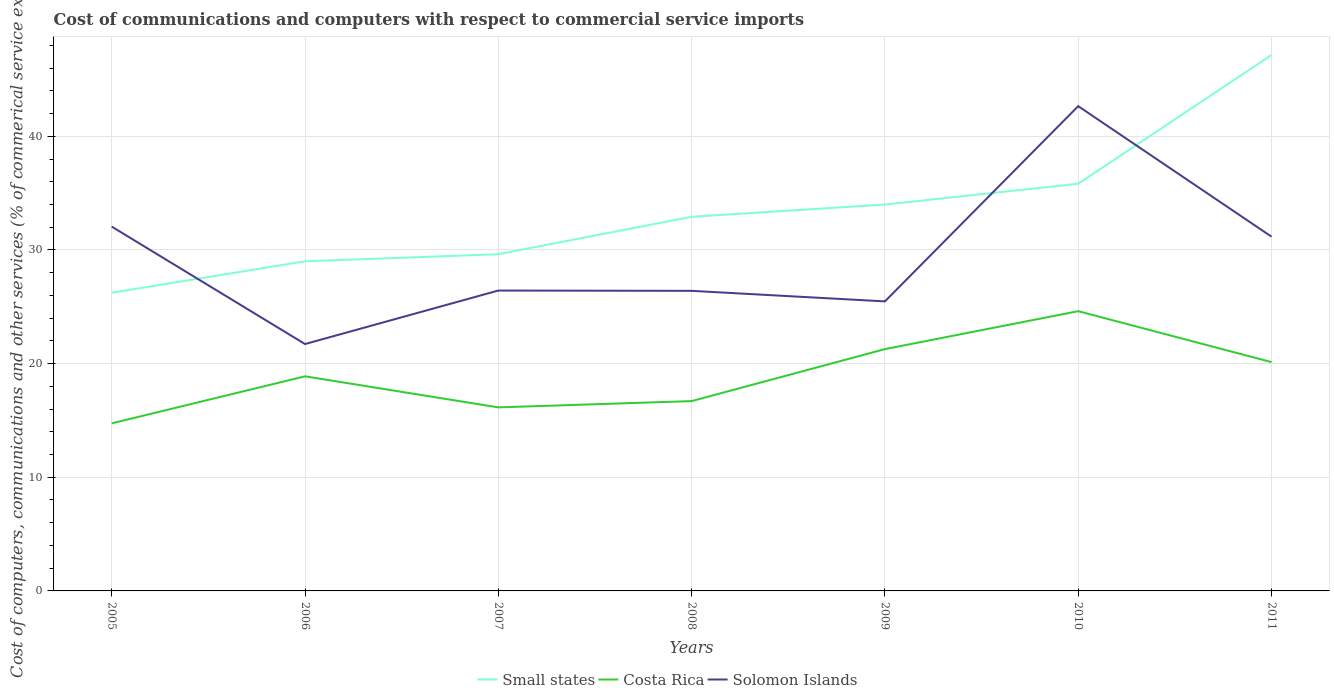How many different coloured lines are there?
Your answer should be very brief. 3. Does the line corresponding to Solomon Islands intersect with the line corresponding to Small states?
Provide a succinct answer. Yes. Across all years, what is the maximum cost of communications and computers in Small states?
Ensure brevity in your answer.  26.24. In which year was the cost of communications and computers in Costa Rica maximum?
Your answer should be very brief. 2005. What is the total cost of communications and computers in Solomon Islands in the graph?
Offer a terse response. 0.95. What is the difference between the highest and the second highest cost of communications and computers in Costa Rica?
Your response must be concise. 9.87. What is the difference between the highest and the lowest cost of communications and computers in Small states?
Make the answer very short. 3. Is the cost of communications and computers in Solomon Islands strictly greater than the cost of communications and computers in Small states over the years?
Offer a terse response. No. Does the graph contain any zero values?
Your response must be concise. No. Does the graph contain grids?
Provide a succinct answer. Yes. Where does the legend appear in the graph?
Your answer should be very brief. Bottom center. How many legend labels are there?
Your response must be concise. 3. How are the legend labels stacked?
Ensure brevity in your answer.  Horizontal. What is the title of the graph?
Offer a very short reply. Cost of communications and computers with respect to commercial service imports. What is the label or title of the X-axis?
Ensure brevity in your answer.  Years. What is the label or title of the Y-axis?
Keep it short and to the point. Cost of computers, communications and other services (% of commerical service exports). What is the Cost of computers, communications and other services (% of commerical service exports) in Small states in 2005?
Give a very brief answer. 26.24. What is the Cost of computers, communications and other services (% of commerical service exports) of Costa Rica in 2005?
Give a very brief answer. 14.74. What is the Cost of computers, communications and other services (% of commerical service exports) in Solomon Islands in 2005?
Give a very brief answer. 32.05. What is the Cost of computers, communications and other services (% of commerical service exports) in Small states in 2006?
Provide a short and direct response. 29. What is the Cost of computers, communications and other services (% of commerical service exports) of Costa Rica in 2006?
Provide a succinct answer. 18.88. What is the Cost of computers, communications and other services (% of commerical service exports) of Solomon Islands in 2006?
Provide a short and direct response. 21.72. What is the Cost of computers, communications and other services (% of commerical service exports) of Small states in 2007?
Keep it short and to the point. 29.62. What is the Cost of computers, communications and other services (% of commerical service exports) in Costa Rica in 2007?
Provide a short and direct response. 16.15. What is the Cost of computers, communications and other services (% of commerical service exports) of Solomon Islands in 2007?
Your answer should be very brief. 26.43. What is the Cost of computers, communications and other services (% of commerical service exports) in Small states in 2008?
Ensure brevity in your answer.  32.92. What is the Cost of computers, communications and other services (% of commerical service exports) of Costa Rica in 2008?
Your answer should be compact. 16.7. What is the Cost of computers, communications and other services (% of commerical service exports) in Solomon Islands in 2008?
Provide a short and direct response. 26.4. What is the Cost of computers, communications and other services (% of commerical service exports) of Small states in 2009?
Provide a short and direct response. 33.99. What is the Cost of computers, communications and other services (% of commerical service exports) in Costa Rica in 2009?
Offer a terse response. 21.27. What is the Cost of computers, communications and other services (% of commerical service exports) in Solomon Islands in 2009?
Offer a very short reply. 25.47. What is the Cost of computers, communications and other services (% of commerical service exports) in Small states in 2010?
Keep it short and to the point. 35.83. What is the Cost of computers, communications and other services (% of commerical service exports) in Costa Rica in 2010?
Provide a succinct answer. 24.61. What is the Cost of computers, communications and other services (% of commerical service exports) in Solomon Islands in 2010?
Provide a short and direct response. 42.65. What is the Cost of computers, communications and other services (% of commerical service exports) of Small states in 2011?
Give a very brief answer. 47.15. What is the Cost of computers, communications and other services (% of commerical service exports) in Costa Rica in 2011?
Offer a very short reply. 20.13. What is the Cost of computers, communications and other services (% of commerical service exports) of Solomon Islands in 2011?
Offer a terse response. 31.17. Across all years, what is the maximum Cost of computers, communications and other services (% of commerical service exports) of Small states?
Keep it short and to the point. 47.15. Across all years, what is the maximum Cost of computers, communications and other services (% of commerical service exports) in Costa Rica?
Provide a succinct answer. 24.61. Across all years, what is the maximum Cost of computers, communications and other services (% of commerical service exports) of Solomon Islands?
Provide a short and direct response. 42.65. Across all years, what is the minimum Cost of computers, communications and other services (% of commerical service exports) of Small states?
Your response must be concise. 26.24. Across all years, what is the minimum Cost of computers, communications and other services (% of commerical service exports) of Costa Rica?
Your answer should be compact. 14.74. Across all years, what is the minimum Cost of computers, communications and other services (% of commerical service exports) of Solomon Islands?
Offer a very short reply. 21.72. What is the total Cost of computers, communications and other services (% of commerical service exports) of Small states in the graph?
Your response must be concise. 234.75. What is the total Cost of computers, communications and other services (% of commerical service exports) in Costa Rica in the graph?
Offer a terse response. 132.49. What is the total Cost of computers, communications and other services (% of commerical service exports) in Solomon Islands in the graph?
Provide a short and direct response. 205.9. What is the difference between the Cost of computers, communications and other services (% of commerical service exports) of Small states in 2005 and that in 2006?
Your answer should be compact. -2.77. What is the difference between the Cost of computers, communications and other services (% of commerical service exports) in Costa Rica in 2005 and that in 2006?
Your response must be concise. -4.14. What is the difference between the Cost of computers, communications and other services (% of commerical service exports) of Solomon Islands in 2005 and that in 2006?
Offer a terse response. 10.33. What is the difference between the Cost of computers, communications and other services (% of commerical service exports) in Small states in 2005 and that in 2007?
Make the answer very short. -3.39. What is the difference between the Cost of computers, communications and other services (% of commerical service exports) of Costa Rica in 2005 and that in 2007?
Give a very brief answer. -1.41. What is the difference between the Cost of computers, communications and other services (% of commerical service exports) of Solomon Islands in 2005 and that in 2007?
Keep it short and to the point. 5.63. What is the difference between the Cost of computers, communications and other services (% of commerical service exports) in Small states in 2005 and that in 2008?
Your response must be concise. -6.68. What is the difference between the Cost of computers, communications and other services (% of commerical service exports) of Costa Rica in 2005 and that in 2008?
Your answer should be compact. -1.96. What is the difference between the Cost of computers, communications and other services (% of commerical service exports) of Solomon Islands in 2005 and that in 2008?
Your answer should be very brief. 5.65. What is the difference between the Cost of computers, communications and other services (% of commerical service exports) in Small states in 2005 and that in 2009?
Provide a succinct answer. -7.76. What is the difference between the Cost of computers, communications and other services (% of commerical service exports) in Costa Rica in 2005 and that in 2009?
Your answer should be compact. -6.53. What is the difference between the Cost of computers, communications and other services (% of commerical service exports) in Solomon Islands in 2005 and that in 2009?
Keep it short and to the point. 6.58. What is the difference between the Cost of computers, communications and other services (% of commerical service exports) in Small states in 2005 and that in 2010?
Your answer should be compact. -9.59. What is the difference between the Cost of computers, communications and other services (% of commerical service exports) in Costa Rica in 2005 and that in 2010?
Your answer should be very brief. -9.87. What is the difference between the Cost of computers, communications and other services (% of commerical service exports) in Solomon Islands in 2005 and that in 2010?
Make the answer very short. -10.6. What is the difference between the Cost of computers, communications and other services (% of commerical service exports) of Small states in 2005 and that in 2011?
Your answer should be compact. -20.92. What is the difference between the Cost of computers, communications and other services (% of commerical service exports) of Costa Rica in 2005 and that in 2011?
Give a very brief answer. -5.39. What is the difference between the Cost of computers, communications and other services (% of commerical service exports) of Solomon Islands in 2005 and that in 2011?
Offer a very short reply. 0.88. What is the difference between the Cost of computers, communications and other services (% of commerical service exports) in Small states in 2006 and that in 2007?
Offer a terse response. -0.62. What is the difference between the Cost of computers, communications and other services (% of commerical service exports) of Costa Rica in 2006 and that in 2007?
Your answer should be compact. 2.73. What is the difference between the Cost of computers, communications and other services (% of commerical service exports) in Solomon Islands in 2006 and that in 2007?
Ensure brevity in your answer.  -4.71. What is the difference between the Cost of computers, communications and other services (% of commerical service exports) in Small states in 2006 and that in 2008?
Your answer should be compact. -3.92. What is the difference between the Cost of computers, communications and other services (% of commerical service exports) in Costa Rica in 2006 and that in 2008?
Offer a very short reply. 2.18. What is the difference between the Cost of computers, communications and other services (% of commerical service exports) in Solomon Islands in 2006 and that in 2008?
Provide a short and direct response. -4.68. What is the difference between the Cost of computers, communications and other services (% of commerical service exports) of Small states in 2006 and that in 2009?
Make the answer very short. -4.99. What is the difference between the Cost of computers, communications and other services (% of commerical service exports) in Costa Rica in 2006 and that in 2009?
Your answer should be compact. -2.39. What is the difference between the Cost of computers, communications and other services (% of commerical service exports) in Solomon Islands in 2006 and that in 2009?
Your answer should be compact. -3.75. What is the difference between the Cost of computers, communications and other services (% of commerical service exports) of Small states in 2006 and that in 2010?
Give a very brief answer. -6.83. What is the difference between the Cost of computers, communications and other services (% of commerical service exports) of Costa Rica in 2006 and that in 2010?
Your answer should be compact. -5.73. What is the difference between the Cost of computers, communications and other services (% of commerical service exports) of Solomon Islands in 2006 and that in 2010?
Your answer should be compact. -20.93. What is the difference between the Cost of computers, communications and other services (% of commerical service exports) in Small states in 2006 and that in 2011?
Make the answer very short. -18.15. What is the difference between the Cost of computers, communications and other services (% of commerical service exports) of Costa Rica in 2006 and that in 2011?
Your answer should be compact. -1.25. What is the difference between the Cost of computers, communications and other services (% of commerical service exports) in Solomon Islands in 2006 and that in 2011?
Provide a short and direct response. -9.45. What is the difference between the Cost of computers, communications and other services (% of commerical service exports) of Small states in 2007 and that in 2008?
Provide a short and direct response. -3.29. What is the difference between the Cost of computers, communications and other services (% of commerical service exports) in Costa Rica in 2007 and that in 2008?
Make the answer very short. -0.55. What is the difference between the Cost of computers, communications and other services (% of commerical service exports) in Solomon Islands in 2007 and that in 2008?
Your response must be concise. 0.03. What is the difference between the Cost of computers, communications and other services (% of commerical service exports) in Small states in 2007 and that in 2009?
Make the answer very short. -4.37. What is the difference between the Cost of computers, communications and other services (% of commerical service exports) of Costa Rica in 2007 and that in 2009?
Offer a very short reply. -5.12. What is the difference between the Cost of computers, communications and other services (% of commerical service exports) of Solomon Islands in 2007 and that in 2009?
Keep it short and to the point. 0.95. What is the difference between the Cost of computers, communications and other services (% of commerical service exports) of Small states in 2007 and that in 2010?
Give a very brief answer. -6.2. What is the difference between the Cost of computers, communications and other services (% of commerical service exports) in Costa Rica in 2007 and that in 2010?
Provide a succinct answer. -8.46. What is the difference between the Cost of computers, communications and other services (% of commerical service exports) of Solomon Islands in 2007 and that in 2010?
Offer a terse response. -16.22. What is the difference between the Cost of computers, communications and other services (% of commerical service exports) in Small states in 2007 and that in 2011?
Provide a short and direct response. -17.53. What is the difference between the Cost of computers, communications and other services (% of commerical service exports) in Costa Rica in 2007 and that in 2011?
Ensure brevity in your answer.  -3.98. What is the difference between the Cost of computers, communications and other services (% of commerical service exports) of Solomon Islands in 2007 and that in 2011?
Keep it short and to the point. -4.74. What is the difference between the Cost of computers, communications and other services (% of commerical service exports) in Small states in 2008 and that in 2009?
Provide a short and direct response. -1.08. What is the difference between the Cost of computers, communications and other services (% of commerical service exports) of Costa Rica in 2008 and that in 2009?
Provide a short and direct response. -4.57. What is the difference between the Cost of computers, communications and other services (% of commerical service exports) of Solomon Islands in 2008 and that in 2009?
Your answer should be very brief. 0.93. What is the difference between the Cost of computers, communications and other services (% of commerical service exports) in Small states in 2008 and that in 2010?
Give a very brief answer. -2.91. What is the difference between the Cost of computers, communications and other services (% of commerical service exports) in Costa Rica in 2008 and that in 2010?
Keep it short and to the point. -7.91. What is the difference between the Cost of computers, communications and other services (% of commerical service exports) in Solomon Islands in 2008 and that in 2010?
Make the answer very short. -16.25. What is the difference between the Cost of computers, communications and other services (% of commerical service exports) in Small states in 2008 and that in 2011?
Provide a short and direct response. -14.23. What is the difference between the Cost of computers, communications and other services (% of commerical service exports) in Costa Rica in 2008 and that in 2011?
Keep it short and to the point. -3.43. What is the difference between the Cost of computers, communications and other services (% of commerical service exports) in Solomon Islands in 2008 and that in 2011?
Your answer should be very brief. -4.77. What is the difference between the Cost of computers, communications and other services (% of commerical service exports) in Small states in 2009 and that in 2010?
Offer a very short reply. -1.83. What is the difference between the Cost of computers, communications and other services (% of commerical service exports) in Costa Rica in 2009 and that in 2010?
Provide a short and direct response. -3.34. What is the difference between the Cost of computers, communications and other services (% of commerical service exports) of Solomon Islands in 2009 and that in 2010?
Keep it short and to the point. -17.18. What is the difference between the Cost of computers, communications and other services (% of commerical service exports) in Small states in 2009 and that in 2011?
Your answer should be compact. -13.16. What is the difference between the Cost of computers, communications and other services (% of commerical service exports) of Costa Rica in 2009 and that in 2011?
Your response must be concise. 1.14. What is the difference between the Cost of computers, communications and other services (% of commerical service exports) of Solomon Islands in 2009 and that in 2011?
Make the answer very short. -5.7. What is the difference between the Cost of computers, communications and other services (% of commerical service exports) of Small states in 2010 and that in 2011?
Your answer should be compact. -11.33. What is the difference between the Cost of computers, communications and other services (% of commerical service exports) of Costa Rica in 2010 and that in 2011?
Provide a short and direct response. 4.48. What is the difference between the Cost of computers, communications and other services (% of commerical service exports) in Solomon Islands in 2010 and that in 2011?
Your answer should be very brief. 11.48. What is the difference between the Cost of computers, communications and other services (% of commerical service exports) of Small states in 2005 and the Cost of computers, communications and other services (% of commerical service exports) of Costa Rica in 2006?
Offer a terse response. 7.35. What is the difference between the Cost of computers, communications and other services (% of commerical service exports) of Small states in 2005 and the Cost of computers, communications and other services (% of commerical service exports) of Solomon Islands in 2006?
Give a very brief answer. 4.51. What is the difference between the Cost of computers, communications and other services (% of commerical service exports) in Costa Rica in 2005 and the Cost of computers, communications and other services (% of commerical service exports) in Solomon Islands in 2006?
Provide a succinct answer. -6.98. What is the difference between the Cost of computers, communications and other services (% of commerical service exports) of Small states in 2005 and the Cost of computers, communications and other services (% of commerical service exports) of Costa Rica in 2007?
Offer a very short reply. 10.09. What is the difference between the Cost of computers, communications and other services (% of commerical service exports) of Small states in 2005 and the Cost of computers, communications and other services (% of commerical service exports) of Solomon Islands in 2007?
Provide a succinct answer. -0.19. What is the difference between the Cost of computers, communications and other services (% of commerical service exports) in Costa Rica in 2005 and the Cost of computers, communications and other services (% of commerical service exports) in Solomon Islands in 2007?
Keep it short and to the point. -11.69. What is the difference between the Cost of computers, communications and other services (% of commerical service exports) in Small states in 2005 and the Cost of computers, communications and other services (% of commerical service exports) in Costa Rica in 2008?
Give a very brief answer. 9.53. What is the difference between the Cost of computers, communications and other services (% of commerical service exports) of Small states in 2005 and the Cost of computers, communications and other services (% of commerical service exports) of Solomon Islands in 2008?
Ensure brevity in your answer.  -0.17. What is the difference between the Cost of computers, communications and other services (% of commerical service exports) in Costa Rica in 2005 and the Cost of computers, communications and other services (% of commerical service exports) in Solomon Islands in 2008?
Provide a succinct answer. -11.66. What is the difference between the Cost of computers, communications and other services (% of commerical service exports) of Small states in 2005 and the Cost of computers, communications and other services (% of commerical service exports) of Costa Rica in 2009?
Offer a very short reply. 4.96. What is the difference between the Cost of computers, communications and other services (% of commerical service exports) in Small states in 2005 and the Cost of computers, communications and other services (% of commerical service exports) in Solomon Islands in 2009?
Your answer should be compact. 0.76. What is the difference between the Cost of computers, communications and other services (% of commerical service exports) of Costa Rica in 2005 and the Cost of computers, communications and other services (% of commerical service exports) of Solomon Islands in 2009?
Your response must be concise. -10.73. What is the difference between the Cost of computers, communications and other services (% of commerical service exports) of Small states in 2005 and the Cost of computers, communications and other services (% of commerical service exports) of Costa Rica in 2010?
Give a very brief answer. 1.62. What is the difference between the Cost of computers, communications and other services (% of commerical service exports) in Small states in 2005 and the Cost of computers, communications and other services (% of commerical service exports) in Solomon Islands in 2010?
Your answer should be compact. -16.42. What is the difference between the Cost of computers, communications and other services (% of commerical service exports) in Costa Rica in 2005 and the Cost of computers, communications and other services (% of commerical service exports) in Solomon Islands in 2010?
Offer a very short reply. -27.91. What is the difference between the Cost of computers, communications and other services (% of commerical service exports) of Small states in 2005 and the Cost of computers, communications and other services (% of commerical service exports) of Costa Rica in 2011?
Give a very brief answer. 6.1. What is the difference between the Cost of computers, communications and other services (% of commerical service exports) of Small states in 2005 and the Cost of computers, communications and other services (% of commerical service exports) of Solomon Islands in 2011?
Make the answer very short. -4.93. What is the difference between the Cost of computers, communications and other services (% of commerical service exports) of Costa Rica in 2005 and the Cost of computers, communications and other services (% of commerical service exports) of Solomon Islands in 2011?
Your response must be concise. -16.43. What is the difference between the Cost of computers, communications and other services (% of commerical service exports) in Small states in 2006 and the Cost of computers, communications and other services (% of commerical service exports) in Costa Rica in 2007?
Keep it short and to the point. 12.85. What is the difference between the Cost of computers, communications and other services (% of commerical service exports) of Small states in 2006 and the Cost of computers, communications and other services (% of commerical service exports) of Solomon Islands in 2007?
Ensure brevity in your answer.  2.57. What is the difference between the Cost of computers, communications and other services (% of commerical service exports) in Costa Rica in 2006 and the Cost of computers, communications and other services (% of commerical service exports) in Solomon Islands in 2007?
Make the answer very short. -7.55. What is the difference between the Cost of computers, communications and other services (% of commerical service exports) in Small states in 2006 and the Cost of computers, communications and other services (% of commerical service exports) in Costa Rica in 2008?
Provide a short and direct response. 12.3. What is the difference between the Cost of computers, communications and other services (% of commerical service exports) in Small states in 2006 and the Cost of computers, communications and other services (% of commerical service exports) in Solomon Islands in 2008?
Provide a succinct answer. 2.6. What is the difference between the Cost of computers, communications and other services (% of commerical service exports) in Costa Rica in 2006 and the Cost of computers, communications and other services (% of commerical service exports) in Solomon Islands in 2008?
Ensure brevity in your answer.  -7.52. What is the difference between the Cost of computers, communications and other services (% of commerical service exports) in Small states in 2006 and the Cost of computers, communications and other services (% of commerical service exports) in Costa Rica in 2009?
Ensure brevity in your answer.  7.73. What is the difference between the Cost of computers, communications and other services (% of commerical service exports) of Small states in 2006 and the Cost of computers, communications and other services (% of commerical service exports) of Solomon Islands in 2009?
Your answer should be compact. 3.53. What is the difference between the Cost of computers, communications and other services (% of commerical service exports) of Costa Rica in 2006 and the Cost of computers, communications and other services (% of commerical service exports) of Solomon Islands in 2009?
Keep it short and to the point. -6.59. What is the difference between the Cost of computers, communications and other services (% of commerical service exports) in Small states in 2006 and the Cost of computers, communications and other services (% of commerical service exports) in Costa Rica in 2010?
Give a very brief answer. 4.39. What is the difference between the Cost of computers, communications and other services (% of commerical service exports) of Small states in 2006 and the Cost of computers, communications and other services (% of commerical service exports) of Solomon Islands in 2010?
Offer a very short reply. -13.65. What is the difference between the Cost of computers, communications and other services (% of commerical service exports) in Costa Rica in 2006 and the Cost of computers, communications and other services (% of commerical service exports) in Solomon Islands in 2010?
Offer a very short reply. -23.77. What is the difference between the Cost of computers, communications and other services (% of commerical service exports) in Small states in 2006 and the Cost of computers, communications and other services (% of commerical service exports) in Costa Rica in 2011?
Keep it short and to the point. 8.87. What is the difference between the Cost of computers, communications and other services (% of commerical service exports) in Small states in 2006 and the Cost of computers, communications and other services (% of commerical service exports) in Solomon Islands in 2011?
Offer a very short reply. -2.17. What is the difference between the Cost of computers, communications and other services (% of commerical service exports) in Costa Rica in 2006 and the Cost of computers, communications and other services (% of commerical service exports) in Solomon Islands in 2011?
Your response must be concise. -12.29. What is the difference between the Cost of computers, communications and other services (% of commerical service exports) in Small states in 2007 and the Cost of computers, communications and other services (% of commerical service exports) in Costa Rica in 2008?
Give a very brief answer. 12.92. What is the difference between the Cost of computers, communications and other services (% of commerical service exports) in Small states in 2007 and the Cost of computers, communications and other services (% of commerical service exports) in Solomon Islands in 2008?
Make the answer very short. 3.22. What is the difference between the Cost of computers, communications and other services (% of commerical service exports) in Costa Rica in 2007 and the Cost of computers, communications and other services (% of commerical service exports) in Solomon Islands in 2008?
Ensure brevity in your answer.  -10.25. What is the difference between the Cost of computers, communications and other services (% of commerical service exports) in Small states in 2007 and the Cost of computers, communications and other services (% of commerical service exports) in Costa Rica in 2009?
Your answer should be compact. 8.35. What is the difference between the Cost of computers, communications and other services (% of commerical service exports) in Small states in 2007 and the Cost of computers, communications and other services (% of commerical service exports) in Solomon Islands in 2009?
Your answer should be compact. 4.15. What is the difference between the Cost of computers, communications and other services (% of commerical service exports) in Costa Rica in 2007 and the Cost of computers, communications and other services (% of commerical service exports) in Solomon Islands in 2009?
Your response must be concise. -9.32. What is the difference between the Cost of computers, communications and other services (% of commerical service exports) in Small states in 2007 and the Cost of computers, communications and other services (% of commerical service exports) in Costa Rica in 2010?
Keep it short and to the point. 5.01. What is the difference between the Cost of computers, communications and other services (% of commerical service exports) in Small states in 2007 and the Cost of computers, communications and other services (% of commerical service exports) in Solomon Islands in 2010?
Provide a succinct answer. -13.03. What is the difference between the Cost of computers, communications and other services (% of commerical service exports) in Costa Rica in 2007 and the Cost of computers, communications and other services (% of commerical service exports) in Solomon Islands in 2010?
Your answer should be compact. -26.5. What is the difference between the Cost of computers, communications and other services (% of commerical service exports) in Small states in 2007 and the Cost of computers, communications and other services (% of commerical service exports) in Costa Rica in 2011?
Ensure brevity in your answer.  9.49. What is the difference between the Cost of computers, communications and other services (% of commerical service exports) of Small states in 2007 and the Cost of computers, communications and other services (% of commerical service exports) of Solomon Islands in 2011?
Provide a short and direct response. -1.55. What is the difference between the Cost of computers, communications and other services (% of commerical service exports) of Costa Rica in 2007 and the Cost of computers, communications and other services (% of commerical service exports) of Solomon Islands in 2011?
Keep it short and to the point. -15.02. What is the difference between the Cost of computers, communications and other services (% of commerical service exports) in Small states in 2008 and the Cost of computers, communications and other services (% of commerical service exports) in Costa Rica in 2009?
Keep it short and to the point. 11.64. What is the difference between the Cost of computers, communications and other services (% of commerical service exports) of Small states in 2008 and the Cost of computers, communications and other services (% of commerical service exports) of Solomon Islands in 2009?
Ensure brevity in your answer.  7.44. What is the difference between the Cost of computers, communications and other services (% of commerical service exports) in Costa Rica in 2008 and the Cost of computers, communications and other services (% of commerical service exports) in Solomon Islands in 2009?
Your answer should be compact. -8.77. What is the difference between the Cost of computers, communications and other services (% of commerical service exports) in Small states in 2008 and the Cost of computers, communications and other services (% of commerical service exports) in Costa Rica in 2010?
Keep it short and to the point. 8.3. What is the difference between the Cost of computers, communications and other services (% of commerical service exports) in Small states in 2008 and the Cost of computers, communications and other services (% of commerical service exports) in Solomon Islands in 2010?
Your answer should be very brief. -9.73. What is the difference between the Cost of computers, communications and other services (% of commerical service exports) in Costa Rica in 2008 and the Cost of computers, communications and other services (% of commerical service exports) in Solomon Islands in 2010?
Offer a very short reply. -25.95. What is the difference between the Cost of computers, communications and other services (% of commerical service exports) of Small states in 2008 and the Cost of computers, communications and other services (% of commerical service exports) of Costa Rica in 2011?
Offer a terse response. 12.79. What is the difference between the Cost of computers, communications and other services (% of commerical service exports) in Small states in 2008 and the Cost of computers, communications and other services (% of commerical service exports) in Solomon Islands in 2011?
Provide a succinct answer. 1.75. What is the difference between the Cost of computers, communications and other services (% of commerical service exports) of Costa Rica in 2008 and the Cost of computers, communications and other services (% of commerical service exports) of Solomon Islands in 2011?
Keep it short and to the point. -14.47. What is the difference between the Cost of computers, communications and other services (% of commerical service exports) in Small states in 2009 and the Cost of computers, communications and other services (% of commerical service exports) in Costa Rica in 2010?
Ensure brevity in your answer.  9.38. What is the difference between the Cost of computers, communications and other services (% of commerical service exports) in Small states in 2009 and the Cost of computers, communications and other services (% of commerical service exports) in Solomon Islands in 2010?
Give a very brief answer. -8.66. What is the difference between the Cost of computers, communications and other services (% of commerical service exports) of Costa Rica in 2009 and the Cost of computers, communications and other services (% of commerical service exports) of Solomon Islands in 2010?
Give a very brief answer. -21.38. What is the difference between the Cost of computers, communications and other services (% of commerical service exports) of Small states in 2009 and the Cost of computers, communications and other services (% of commerical service exports) of Costa Rica in 2011?
Provide a short and direct response. 13.86. What is the difference between the Cost of computers, communications and other services (% of commerical service exports) in Small states in 2009 and the Cost of computers, communications and other services (% of commerical service exports) in Solomon Islands in 2011?
Keep it short and to the point. 2.82. What is the difference between the Cost of computers, communications and other services (% of commerical service exports) in Costa Rica in 2009 and the Cost of computers, communications and other services (% of commerical service exports) in Solomon Islands in 2011?
Ensure brevity in your answer.  -9.9. What is the difference between the Cost of computers, communications and other services (% of commerical service exports) in Small states in 2010 and the Cost of computers, communications and other services (% of commerical service exports) in Costa Rica in 2011?
Offer a terse response. 15.69. What is the difference between the Cost of computers, communications and other services (% of commerical service exports) in Small states in 2010 and the Cost of computers, communications and other services (% of commerical service exports) in Solomon Islands in 2011?
Your answer should be compact. 4.66. What is the difference between the Cost of computers, communications and other services (% of commerical service exports) of Costa Rica in 2010 and the Cost of computers, communications and other services (% of commerical service exports) of Solomon Islands in 2011?
Your answer should be compact. -6.56. What is the average Cost of computers, communications and other services (% of commerical service exports) of Small states per year?
Your response must be concise. 33.54. What is the average Cost of computers, communications and other services (% of commerical service exports) in Costa Rica per year?
Offer a very short reply. 18.93. What is the average Cost of computers, communications and other services (% of commerical service exports) in Solomon Islands per year?
Your answer should be very brief. 29.41. In the year 2005, what is the difference between the Cost of computers, communications and other services (% of commerical service exports) in Small states and Cost of computers, communications and other services (% of commerical service exports) in Costa Rica?
Offer a very short reply. 11.49. In the year 2005, what is the difference between the Cost of computers, communications and other services (% of commerical service exports) of Small states and Cost of computers, communications and other services (% of commerical service exports) of Solomon Islands?
Your response must be concise. -5.82. In the year 2005, what is the difference between the Cost of computers, communications and other services (% of commerical service exports) in Costa Rica and Cost of computers, communications and other services (% of commerical service exports) in Solomon Islands?
Your response must be concise. -17.31. In the year 2006, what is the difference between the Cost of computers, communications and other services (% of commerical service exports) in Small states and Cost of computers, communications and other services (% of commerical service exports) in Costa Rica?
Ensure brevity in your answer.  10.12. In the year 2006, what is the difference between the Cost of computers, communications and other services (% of commerical service exports) in Small states and Cost of computers, communications and other services (% of commerical service exports) in Solomon Islands?
Offer a terse response. 7.28. In the year 2006, what is the difference between the Cost of computers, communications and other services (% of commerical service exports) of Costa Rica and Cost of computers, communications and other services (% of commerical service exports) of Solomon Islands?
Provide a succinct answer. -2.84. In the year 2007, what is the difference between the Cost of computers, communications and other services (% of commerical service exports) of Small states and Cost of computers, communications and other services (% of commerical service exports) of Costa Rica?
Provide a short and direct response. 13.47. In the year 2007, what is the difference between the Cost of computers, communications and other services (% of commerical service exports) of Small states and Cost of computers, communications and other services (% of commerical service exports) of Solomon Islands?
Your answer should be compact. 3.2. In the year 2007, what is the difference between the Cost of computers, communications and other services (% of commerical service exports) of Costa Rica and Cost of computers, communications and other services (% of commerical service exports) of Solomon Islands?
Provide a succinct answer. -10.28. In the year 2008, what is the difference between the Cost of computers, communications and other services (% of commerical service exports) of Small states and Cost of computers, communications and other services (% of commerical service exports) of Costa Rica?
Provide a succinct answer. 16.22. In the year 2008, what is the difference between the Cost of computers, communications and other services (% of commerical service exports) of Small states and Cost of computers, communications and other services (% of commerical service exports) of Solomon Islands?
Ensure brevity in your answer.  6.52. In the year 2008, what is the difference between the Cost of computers, communications and other services (% of commerical service exports) of Costa Rica and Cost of computers, communications and other services (% of commerical service exports) of Solomon Islands?
Ensure brevity in your answer.  -9.7. In the year 2009, what is the difference between the Cost of computers, communications and other services (% of commerical service exports) in Small states and Cost of computers, communications and other services (% of commerical service exports) in Costa Rica?
Ensure brevity in your answer.  12.72. In the year 2009, what is the difference between the Cost of computers, communications and other services (% of commerical service exports) of Small states and Cost of computers, communications and other services (% of commerical service exports) of Solomon Islands?
Make the answer very short. 8.52. In the year 2009, what is the difference between the Cost of computers, communications and other services (% of commerical service exports) in Costa Rica and Cost of computers, communications and other services (% of commerical service exports) in Solomon Islands?
Provide a short and direct response. -4.2. In the year 2010, what is the difference between the Cost of computers, communications and other services (% of commerical service exports) of Small states and Cost of computers, communications and other services (% of commerical service exports) of Costa Rica?
Your answer should be very brief. 11.21. In the year 2010, what is the difference between the Cost of computers, communications and other services (% of commerical service exports) of Small states and Cost of computers, communications and other services (% of commerical service exports) of Solomon Islands?
Keep it short and to the point. -6.83. In the year 2010, what is the difference between the Cost of computers, communications and other services (% of commerical service exports) of Costa Rica and Cost of computers, communications and other services (% of commerical service exports) of Solomon Islands?
Your answer should be compact. -18.04. In the year 2011, what is the difference between the Cost of computers, communications and other services (% of commerical service exports) in Small states and Cost of computers, communications and other services (% of commerical service exports) in Costa Rica?
Your answer should be compact. 27.02. In the year 2011, what is the difference between the Cost of computers, communications and other services (% of commerical service exports) of Small states and Cost of computers, communications and other services (% of commerical service exports) of Solomon Islands?
Your response must be concise. 15.98. In the year 2011, what is the difference between the Cost of computers, communications and other services (% of commerical service exports) of Costa Rica and Cost of computers, communications and other services (% of commerical service exports) of Solomon Islands?
Offer a very short reply. -11.04. What is the ratio of the Cost of computers, communications and other services (% of commerical service exports) in Small states in 2005 to that in 2006?
Provide a short and direct response. 0.9. What is the ratio of the Cost of computers, communications and other services (% of commerical service exports) in Costa Rica in 2005 to that in 2006?
Make the answer very short. 0.78. What is the ratio of the Cost of computers, communications and other services (% of commerical service exports) in Solomon Islands in 2005 to that in 2006?
Your answer should be very brief. 1.48. What is the ratio of the Cost of computers, communications and other services (% of commerical service exports) of Small states in 2005 to that in 2007?
Keep it short and to the point. 0.89. What is the ratio of the Cost of computers, communications and other services (% of commerical service exports) in Costa Rica in 2005 to that in 2007?
Ensure brevity in your answer.  0.91. What is the ratio of the Cost of computers, communications and other services (% of commerical service exports) in Solomon Islands in 2005 to that in 2007?
Provide a succinct answer. 1.21. What is the ratio of the Cost of computers, communications and other services (% of commerical service exports) of Small states in 2005 to that in 2008?
Offer a very short reply. 0.8. What is the ratio of the Cost of computers, communications and other services (% of commerical service exports) in Costa Rica in 2005 to that in 2008?
Ensure brevity in your answer.  0.88. What is the ratio of the Cost of computers, communications and other services (% of commerical service exports) in Solomon Islands in 2005 to that in 2008?
Provide a succinct answer. 1.21. What is the ratio of the Cost of computers, communications and other services (% of commerical service exports) of Small states in 2005 to that in 2009?
Keep it short and to the point. 0.77. What is the ratio of the Cost of computers, communications and other services (% of commerical service exports) in Costa Rica in 2005 to that in 2009?
Make the answer very short. 0.69. What is the ratio of the Cost of computers, communications and other services (% of commerical service exports) of Solomon Islands in 2005 to that in 2009?
Provide a short and direct response. 1.26. What is the ratio of the Cost of computers, communications and other services (% of commerical service exports) of Small states in 2005 to that in 2010?
Offer a terse response. 0.73. What is the ratio of the Cost of computers, communications and other services (% of commerical service exports) in Costa Rica in 2005 to that in 2010?
Make the answer very short. 0.6. What is the ratio of the Cost of computers, communications and other services (% of commerical service exports) of Solomon Islands in 2005 to that in 2010?
Provide a short and direct response. 0.75. What is the ratio of the Cost of computers, communications and other services (% of commerical service exports) of Small states in 2005 to that in 2011?
Provide a succinct answer. 0.56. What is the ratio of the Cost of computers, communications and other services (% of commerical service exports) of Costa Rica in 2005 to that in 2011?
Offer a very short reply. 0.73. What is the ratio of the Cost of computers, communications and other services (% of commerical service exports) in Solomon Islands in 2005 to that in 2011?
Your answer should be compact. 1.03. What is the ratio of the Cost of computers, communications and other services (% of commerical service exports) in Small states in 2006 to that in 2007?
Provide a succinct answer. 0.98. What is the ratio of the Cost of computers, communications and other services (% of commerical service exports) of Costa Rica in 2006 to that in 2007?
Your answer should be very brief. 1.17. What is the ratio of the Cost of computers, communications and other services (% of commerical service exports) of Solomon Islands in 2006 to that in 2007?
Provide a succinct answer. 0.82. What is the ratio of the Cost of computers, communications and other services (% of commerical service exports) of Small states in 2006 to that in 2008?
Offer a terse response. 0.88. What is the ratio of the Cost of computers, communications and other services (% of commerical service exports) in Costa Rica in 2006 to that in 2008?
Offer a terse response. 1.13. What is the ratio of the Cost of computers, communications and other services (% of commerical service exports) of Solomon Islands in 2006 to that in 2008?
Your answer should be very brief. 0.82. What is the ratio of the Cost of computers, communications and other services (% of commerical service exports) of Small states in 2006 to that in 2009?
Your response must be concise. 0.85. What is the ratio of the Cost of computers, communications and other services (% of commerical service exports) in Costa Rica in 2006 to that in 2009?
Keep it short and to the point. 0.89. What is the ratio of the Cost of computers, communications and other services (% of commerical service exports) of Solomon Islands in 2006 to that in 2009?
Your response must be concise. 0.85. What is the ratio of the Cost of computers, communications and other services (% of commerical service exports) of Small states in 2006 to that in 2010?
Your answer should be compact. 0.81. What is the ratio of the Cost of computers, communications and other services (% of commerical service exports) in Costa Rica in 2006 to that in 2010?
Make the answer very short. 0.77. What is the ratio of the Cost of computers, communications and other services (% of commerical service exports) in Solomon Islands in 2006 to that in 2010?
Keep it short and to the point. 0.51. What is the ratio of the Cost of computers, communications and other services (% of commerical service exports) of Small states in 2006 to that in 2011?
Provide a succinct answer. 0.61. What is the ratio of the Cost of computers, communications and other services (% of commerical service exports) in Costa Rica in 2006 to that in 2011?
Give a very brief answer. 0.94. What is the ratio of the Cost of computers, communications and other services (% of commerical service exports) in Solomon Islands in 2006 to that in 2011?
Offer a very short reply. 0.7. What is the ratio of the Cost of computers, communications and other services (% of commerical service exports) of Small states in 2007 to that in 2008?
Your answer should be very brief. 0.9. What is the ratio of the Cost of computers, communications and other services (% of commerical service exports) of Costa Rica in 2007 to that in 2008?
Ensure brevity in your answer.  0.97. What is the ratio of the Cost of computers, communications and other services (% of commerical service exports) in Small states in 2007 to that in 2009?
Your answer should be compact. 0.87. What is the ratio of the Cost of computers, communications and other services (% of commerical service exports) in Costa Rica in 2007 to that in 2009?
Ensure brevity in your answer.  0.76. What is the ratio of the Cost of computers, communications and other services (% of commerical service exports) in Solomon Islands in 2007 to that in 2009?
Your response must be concise. 1.04. What is the ratio of the Cost of computers, communications and other services (% of commerical service exports) of Small states in 2007 to that in 2010?
Your response must be concise. 0.83. What is the ratio of the Cost of computers, communications and other services (% of commerical service exports) in Costa Rica in 2007 to that in 2010?
Keep it short and to the point. 0.66. What is the ratio of the Cost of computers, communications and other services (% of commerical service exports) of Solomon Islands in 2007 to that in 2010?
Provide a short and direct response. 0.62. What is the ratio of the Cost of computers, communications and other services (% of commerical service exports) of Small states in 2007 to that in 2011?
Provide a short and direct response. 0.63. What is the ratio of the Cost of computers, communications and other services (% of commerical service exports) of Costa Rica in 2007 to that in 2011?
Your answer should be very brief. 0.8. What is the ratio of the Cost of computers, communications and other services (% of commerical service exports) of Solomon Islands in 2007 to that in 2011?
Keep it short and to the point. 0.85. What is the ratio of the Cost of computers, communications and other services (% of commerical service exports) of Small states in 2008 to that in 2009?
Offer a terse response. 0.97. What is the ratio of the Cost of computers, communications and other services (% of commerical service exports) of Costa Rica in 2008 to that in 2009?
Your response must be concise. 0.79. What is the ratio of the Cost of computers, communications and other services (% of commerical service exports) of Solomon Islands in 2008 to that in 2009?
Your answer should be compact. 1.04. What is the ratio of the Cost of computers, communications and other services (% of commerical service exports) of Small states in 2008 to that in 2010?
Offer a terse response. 0.92. What is the ratio of the Cost of computers, communications and other services (% of commerical service exports) in Costa Rica in 2008 to that in 2010?
Provide a succinct answer. 0.68. What is the ratio of the Cost of computers, communications and other services (% of commerical service exports) of Solomon Islands in 2008 to that in 2010?
Offer a terse response. 0.62. What is the ratio of the Cost of computers, communications and other services (% of commerical service exports) in Small states in 2008 to that in 2011?
Provide a short and direct response. 0.7. What is the ratio of the Cost of computers, communications and other services (% of commerical service exports) of Costa Rica in 2008 to that in 2011?
Offer a very short reply. 0.83. What is the ratio of the Cost of computers, communications and other services (% of commerical service exports) of Solomon Islands in 2008 to that in 2011?
Your response must be concise. 0.85. What is the ratio of the Cost of computers, communications and other services (% of commerical service exports) of Small states in 2009 to that in 2010?
Your response must be concise. 0.95. What is the ratio of the Cost of computers, communications and other services (% of commerical service exports) in Costa Rica in 2009 to that in 2010?
Ensure brevity in your answer.  0.86. What is the ratio of the Cost of computers, communications and other services (% of commerical service exports) of Solomon Islands in 2009 to that in 2010?
Your response must be concise. 0.6. What is the ratio of the Cost of computers, communications and other services (% of commerical service exports) in Small states in 2009 to that in 2011?
Give a very brief answer. 0.72. What is the ratio of the Cost of computers, communications and other services (% of commerical service exports) of Costa Rica in 2009 to that in 2011?
Provide a succinct answer. 1.06. What is the ratio of the Cost of computers, communications and other services (% of commerical service exports) in Solomon Islands in 2009 to that in 2011?
Ensure brevity in your answer.  0.82. What is the ratio of the Cost of computers, communications and other services (% of commerical service exports) in Small states in 2010 to that in 2011?
Give a very brief answer. 0.76. What is the ratio of the Cost of computers, communications and other services (% of commerical service exports) in Costa Rica in 2010 to that in 2011?
Ensure brevity in your answer.  1.22. What is the ratio of the Cost of computers, communications and other services (% of commerical service exports) in Solomon Islands in 2010 to that in 2011?
Your answer should be compact. 1.37. What is the difference between the highest and the second highest Cost of computers, communications and other services (% of commerical service exports) in Small states?
Make the answer very short. 11.33. What is the difference between the highest and the second highest Cost of computers, communications and other services (% of commerical service exports) in Costa Rica?
Your response must be concise. 3.34. What is the difference between the highest and the second highest Cost of computers, communications and other services (% of commerical service exports) of Solomon Islands?
Keep it short and to the point. 10.6. What is the difference between the highest and the lowest Cost of computers, communications and other services (% of commerical service exports) in Small states?
Ensure brevity in your answer.  20.92. What is the difference between the highest and the lowest Cost of computers, communications and other services (% of commerical service exports) in Costa Rica?
Ensure brevity in your answer.  9.87. What is the difference between the highest and the lowest Cost of computers, communications and other services (% of commerical service exports) in Solomon Islands?
Offer a terse response. 20.93. 